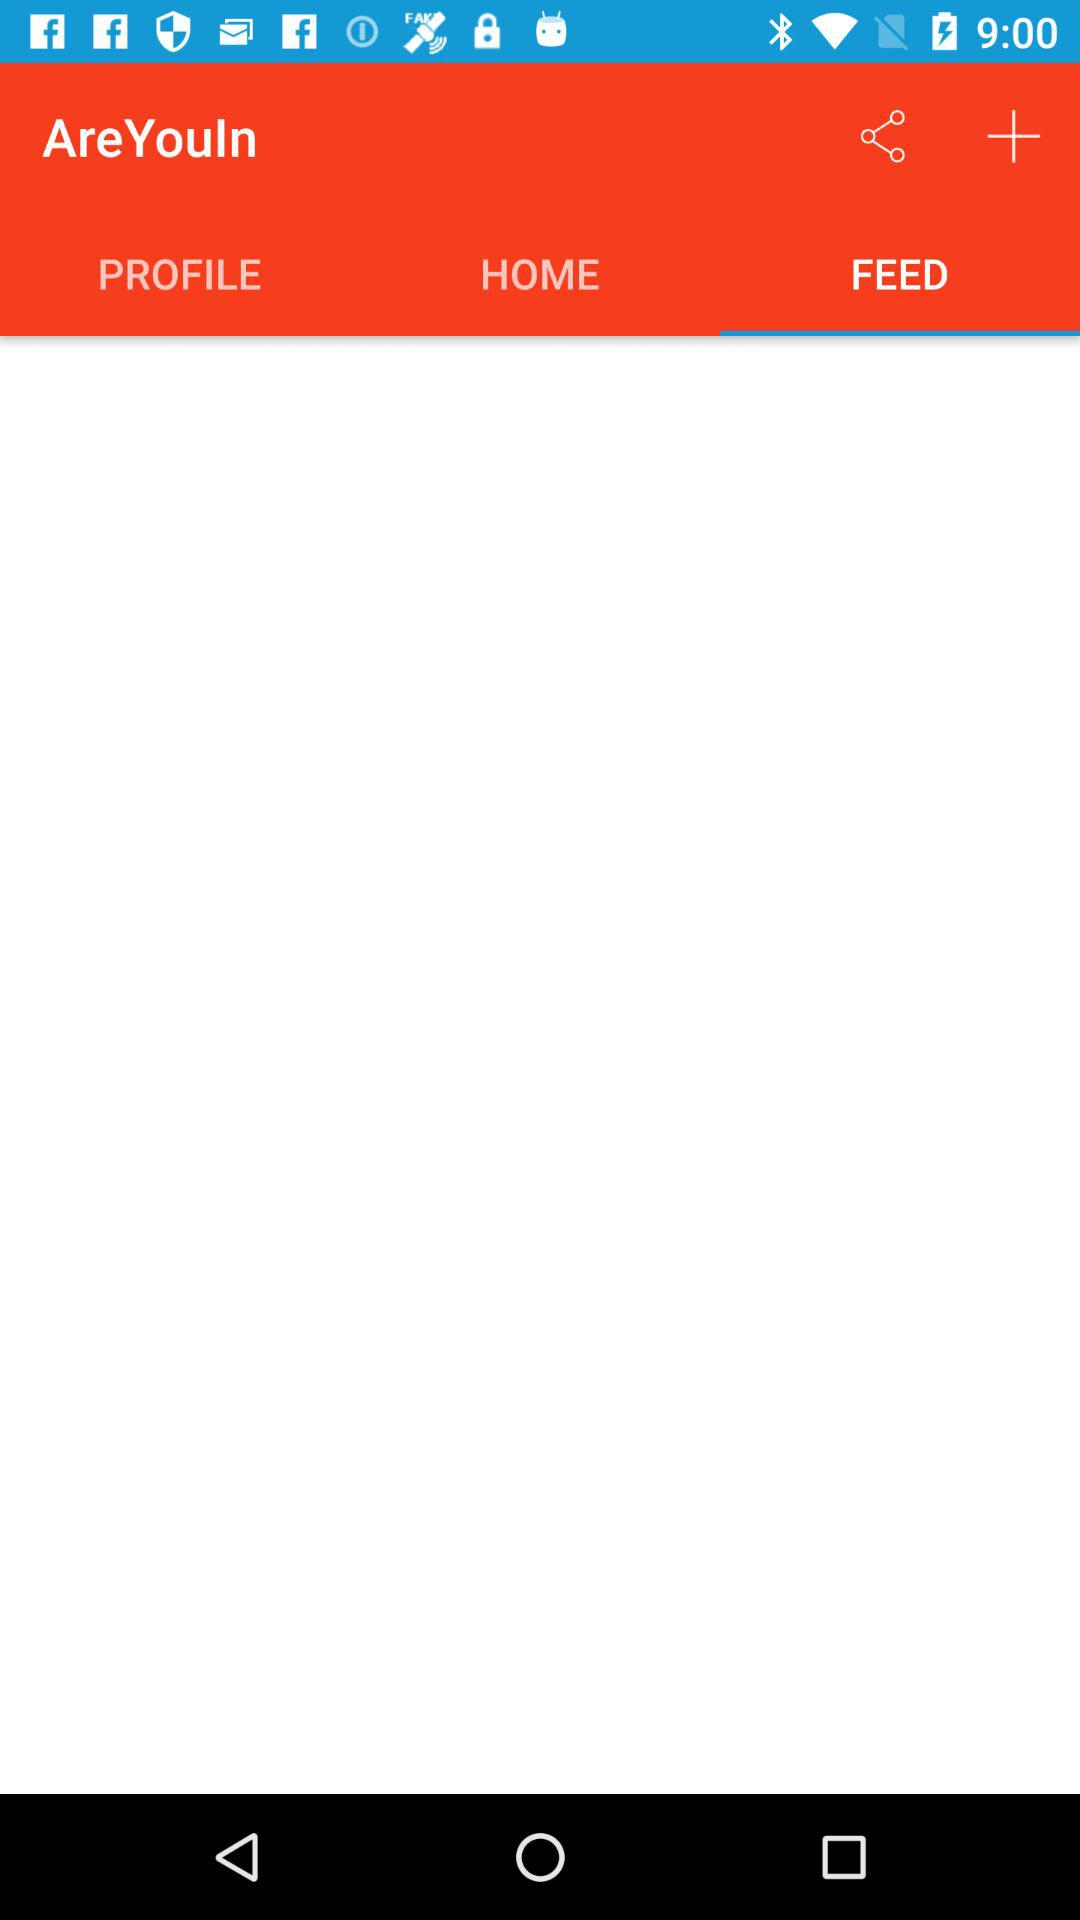Which tab am I on? You are on the "FEED" tab. 